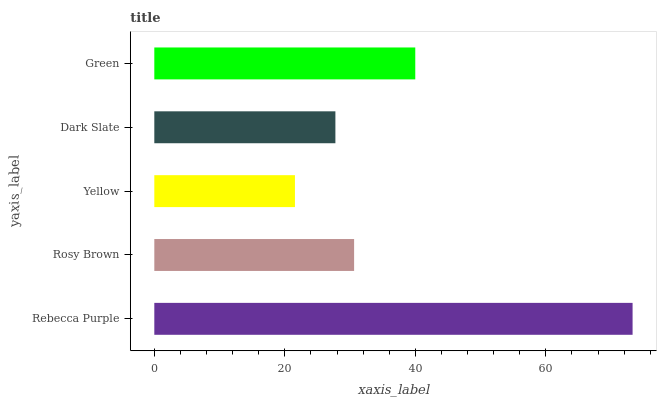Is Yellow the minimum?
Answer yes or no. Yes. Is Rebecca Purple the maximum?
Answer yes or no. Yes. Is Rosy Brown the minimum?
Answer yes or no. No. Is Rosy Brown the maximum?
Answer yes or no. No. Is Rebecca Purple greater than Rosy Brown?
Answer yes or no. Yes. Is Rosy Brown less than Rebecca Purple?
Answer yes or no. Yes. Is Rosy Brown greater than Rebecca Purple?
Answer yes or no. No. Is Rebecca Purple less than Rosy Brown?
Answer yes or no. No. Is Rosy Brown the high median?
Answer yes or no. Yes. Is Rosy Brown the low median?
Answer yes or no. Yes. Is Dark Slate the high median?
Answer yes or no. No. Is Rebecca Purple the low median?
Answer yes or no. No. 